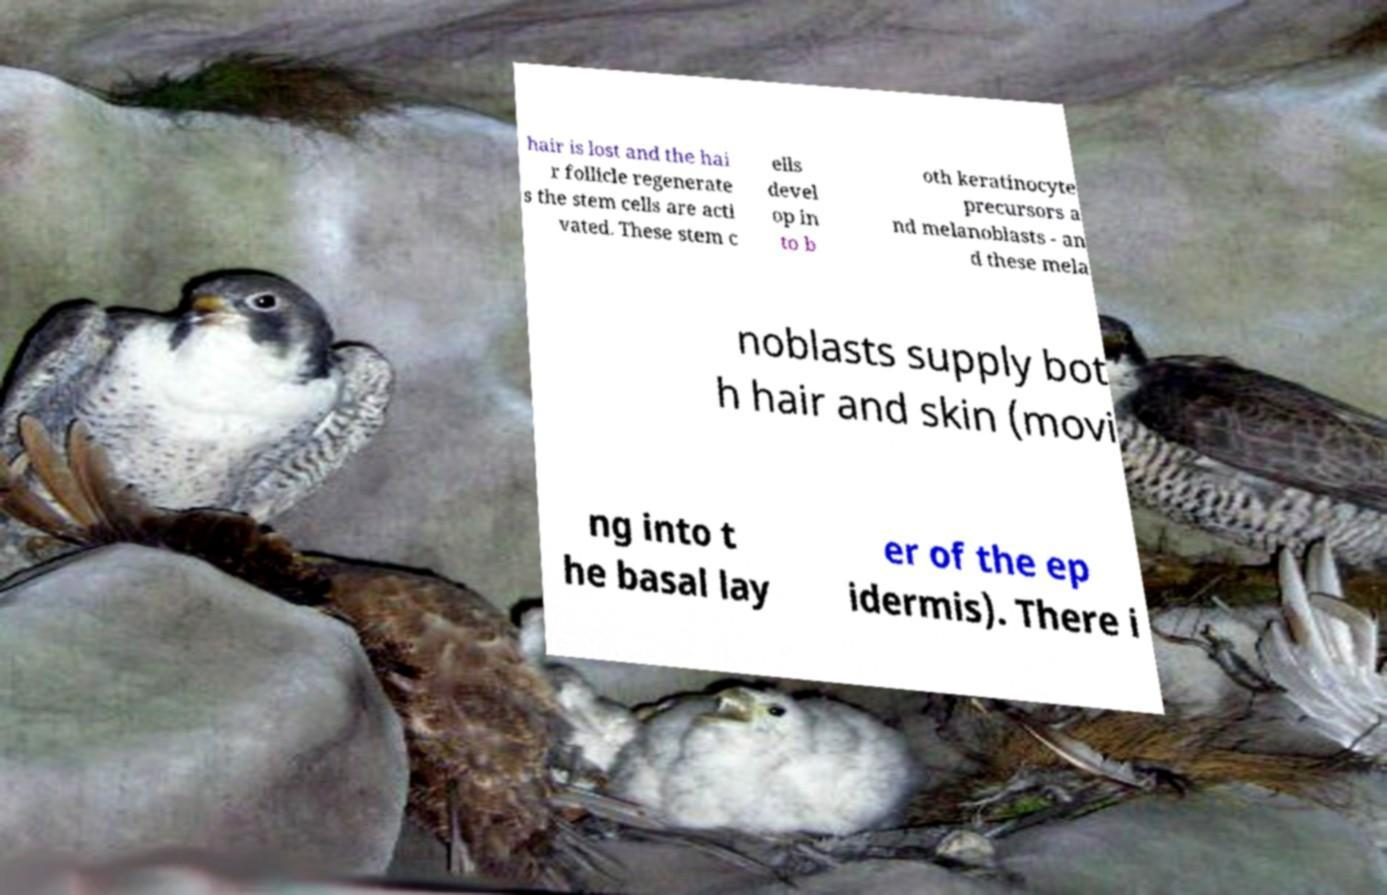What messages or text are displayed in this image? I need them in a readable, typed format. hair is lost and the hai r follicle regenerate s the stem cells are acti vated. These stem c ells devel op in to b oth keratinocyte precursors a nd melanoblasts - an d these mela noblasts supply bot h hair and skin (movi ng into t he basal lay er of the ep idermis). There i 